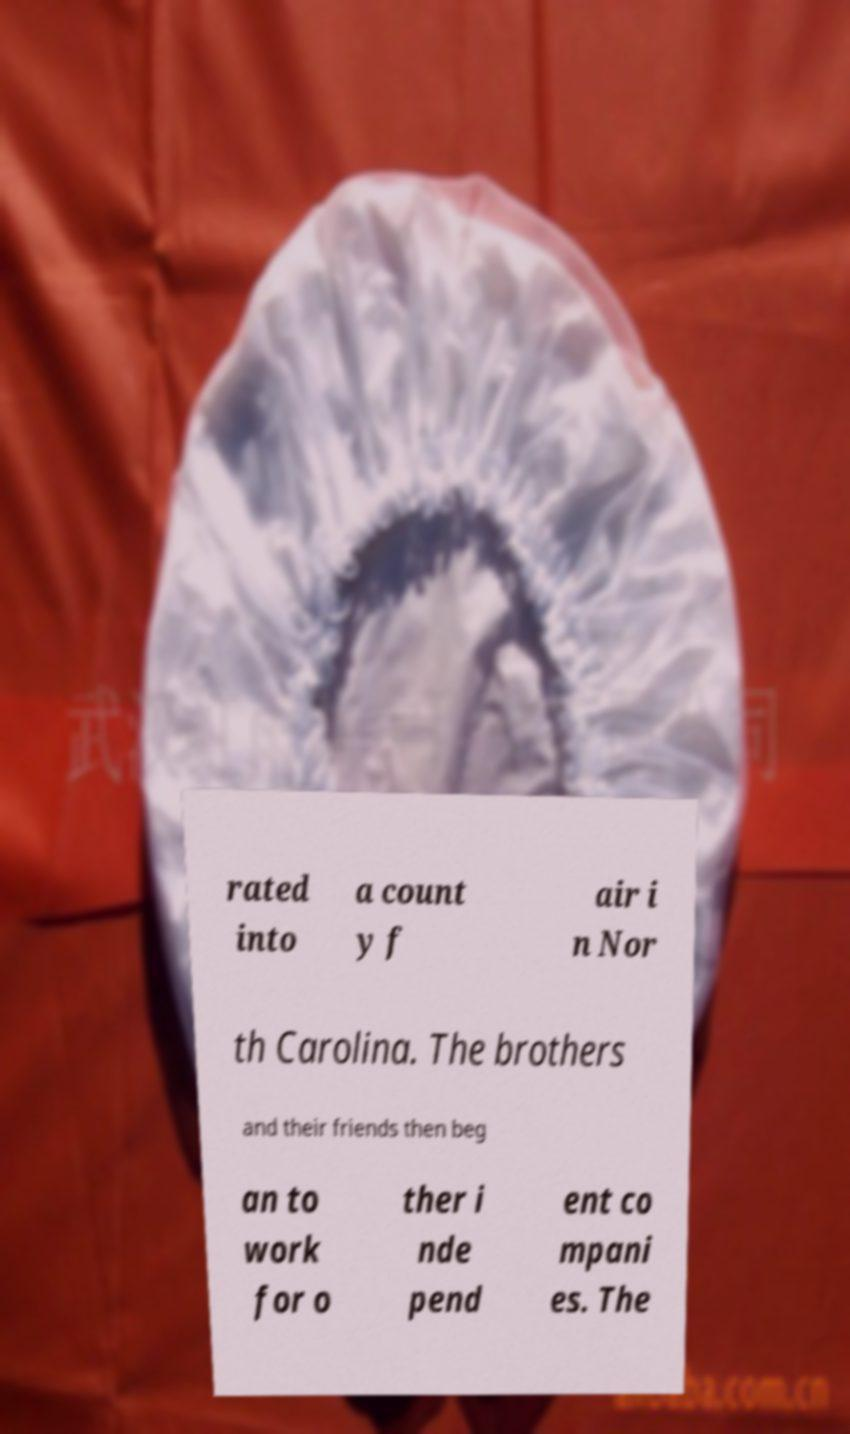There's text embedded in this image that I need extracted. Can you transcribe it verbatim? rated into a count y f air i n Nor th Carolina. The brothers and their friends then beg an to work for o ther i nde pend ent co mpani es. The 